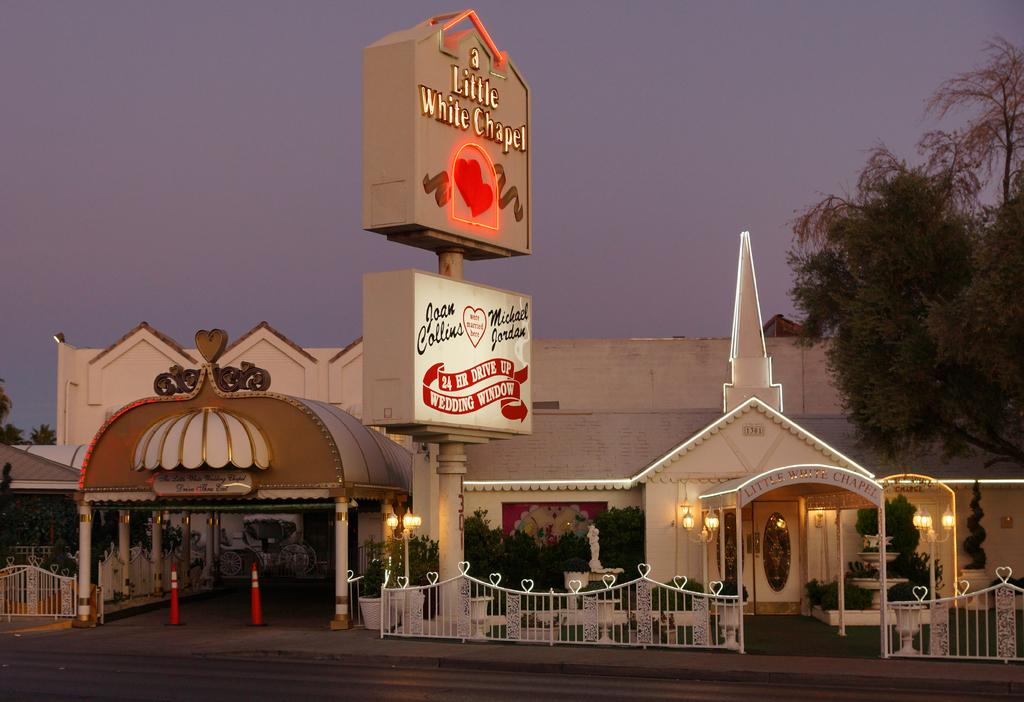What type of structures can be seen in the image? There are buildings in the image. What are the vertical structures on the sides of the streets? Street poles are visible in the image. What are the illuminating devices on the street poles? Street lights are present in the image. What type of cooking appliances can be seen in the image? Grills are in the image. What type of plants are present inside the buildings? House plants are in the image. What type of vegetation is visible in the image? Trees are visible in the image. What type of signs are present in the image? Name boards are present in the image. What is visible in the background of the image? The sky is visible in the image. Can you see any trains passing by in the image? There is no train present in the image. Is there any mist visible in the image? There is no mention of mist in the provided facts, and it is not visible in the image. Are there any bats flying in the image? There is no mention of bats in the provided facts, and they are not visible in the image. 